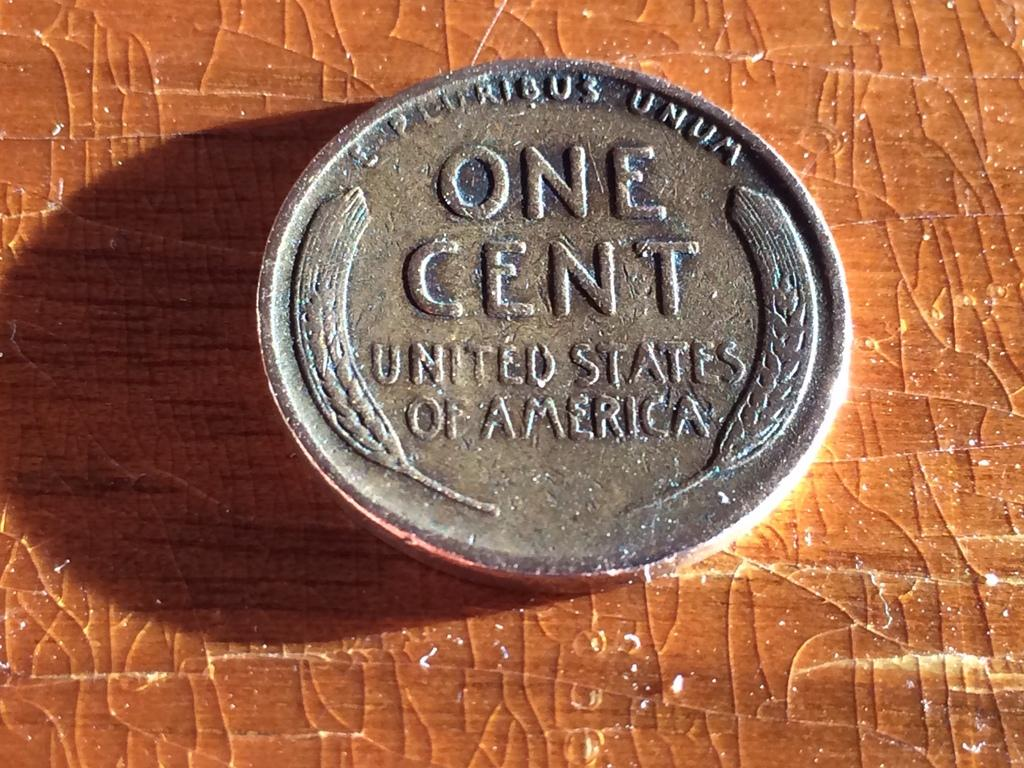<image>
Provide a brief description of the given image. The back of the wheat penny reads, "E Pluribus Unum, One Cent, United States of America". 